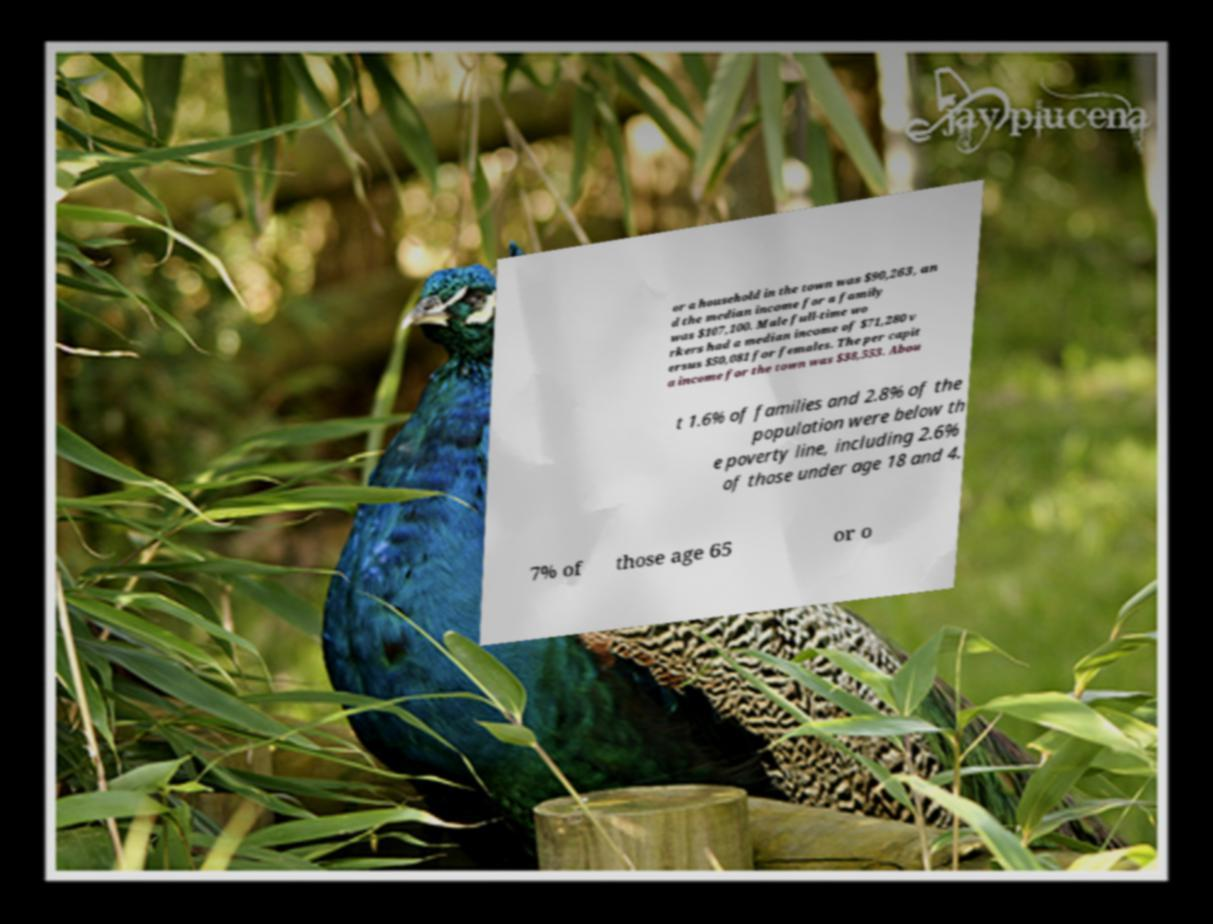Please read and relay the text visible in this image. What does it say? or a household in the town was $90,263, an d the median income for a family was $107,100. Male full-time wo rkers had a median income of $71,280 v ersus $50,081 for females. The per capit a income for the town was $38,553. Abou t 1.6% of families and 2.8% of the population were below th e poverty line, including 2.6% of those under age 18 and 4. 7% of those age 65 or o 